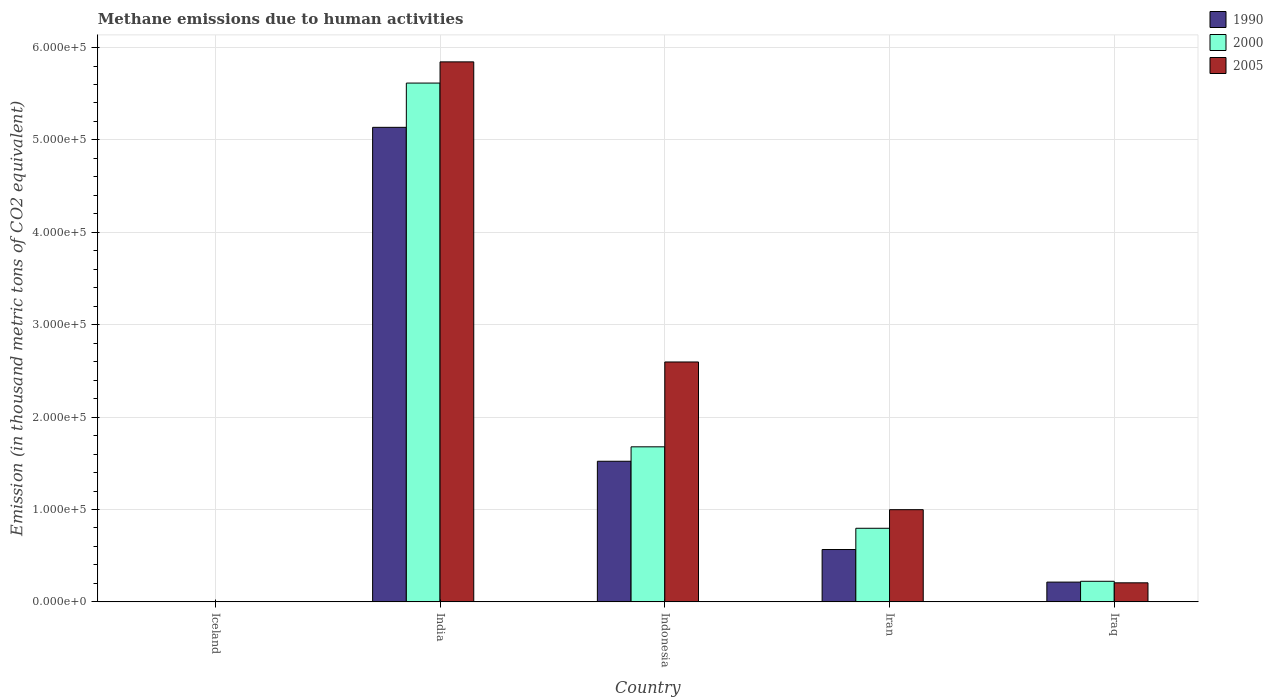How many different coloured bars are there?
Provide a succinct answer. 3. What is the label of the 5th group of bars from the left?
Provide a succinct answer. Iraq. What is the amount of methane emitted in 1990 in India?
Your response must be concise. 5.14e+05. Across all countries, what is the maximum amount of methane emitted in 2005?
Your response must be concise. 5.84e+05. Across all countries, what is the minimum amount of methane emitted in 2000?
Offer a very short reply. 336.5. What is the total amount of methane emitted in 2005 in the graph?
Make the answer very short. 9.65e+05. What is the difference between the amount of methane emitted in 2005 in India and that in Iraq?
Offer a very short reply. 5.64e+05. What is the difference between the amount of methane emitted in 1990 in India and the amount of methane emitted in 2005 in Iceland?
Make the answer very short. 5.13e+05. What is the average amount of methane emitted in 2000 per country?
Keep it short and to the point. 1.66e+05. What is the difference between the amount of methane emitted of/in 2005 and amount of methane emitted of/in 2000 in Iceland?
Your answer should be compact. -0.6. In how many countries, is the amount of methane emitted in 2000 greater than 140000 thousand metric tons?
Offer a terse response. 2. What is the ratio of the amount of methane emitted in 2005 in Indonesia to that in Iran?
Provide a short and direct response. 2.6. What is the difference between the highest and the second highest amount of methane emitted in 2005?
Ensure brevity in your answer.  -3.25e+05. What is the difference between the highest and the lowest amount of methane emitted in 2005?
Provide a succinct answer. 5.84e+05. In how many countries, is the amount of methane emitted in 2005 greater than the average amount of methane emitted in 2005 taken over all countries?
Keep it short and to the point. 2. What does the 1st bar from the left in Iraq represents?
Provide a short and direct response. 1990. What does the 3rd bar from the right in Iraq represents?
Your answer should be very brief. 1990. Is it the case that in every country, the sum of the amount of methane emitted in 2000 and amount of methane emitted in 1990 is greater than the amount of methane emitted in 2005?
Provide a short and direct response. Yes. How many countries are there in the graph?
Provide a short and direct response. 5. What is the title of the graph?
Provide a succinct answer. Methane emissions due to human activities. What is the label or title of the X-axis?
Your response must be concise. Country. What is the label or title of the Y-axis?
Offer a terse response. Emission (in thousand metric tons of CO2 equivalent). What is the Emission (in thousand metric tons of CO2 equivalent) in 1990 in Iceland?
Make the answer very short. 341.7. What is the Emission (in thousand metric tons of CO2 equivalent) of 2000 in Iceland?
Give a very brief answer. 336.5. What is the Emission (in thousand metric tons of CO2 equivalent) in 2005 in Iceland?
Your response must be concise. 335.9. What is the Emission (in thousand metric tons of CO2 equivalent) of 1990 in India?
Give a very brief answer. 5.14e+05. What is the Emission (in thousand metric tons of CO2 equivalent) of 2000 in India?
Your response must be concise. 5.62e+05. What is the Emission (in thousand metric tons of CO2 equivalent) of 2005 in India?
Your response must be concise. 5.84e+05. What is the Emission (in thousand metric tons of CO2 equivalent) of 1990 in Indonesia?
Your answer should be compact. 1.52e+05. What is the Emission (in thousand metric tons of CO2 equivalent) in 2000 in Indonesia?
Your answer should be very brief. 1.68e+05. What is the Emission (in thousand metric tons of CO2 equivalent) in 2005 in Indonesia?
Make the answer very short. 2.60e+05. What is the Emission (in thousand metric tons of CO2 equivalent) of 1990 in Iran?
Provide a short and direct response. 5.67e+04. What is the Emission (in thousand metric tons of CO2 equivalent) of 2000 in Iran?
Your answer should be compact. 7.97e+04. What is the Emission (in thousand metric tons of CO2 equivalent) of 2005 in Iran?
Your answer should be very brief. 9.98e+04. What is the Emission (in thousand metric tons of CO2 equivalent) in 1990 in Iraq?
Offer a very short reply. 2.14e+04. What is the Emission (in thousand metric tons of CO2 equivalent) in 2000 in Iraq?
Your answer should be compact. 2.23e+04. What is the Emission (in thousand metric tons of CO2 equivalent) in 2005 in Iraq?
Your answer should be very brief. 2.06e+04. Across all countries, what is the maximum Emission (in thousand metric tons of CO2 equivalent) in 1990?
Your answer should be compact. 5.14e+05. Across all countries, what is the maximum Emission (in thousand metric tons of CO2 equivalent) of 2000?
Your answer should be very brief. 5.62e+05. Across all countries, what is the maximum Emission (in thousand metric tons of CO2 equivalent) in 2005?
Offer a very short reply. 5.84e+05. Across all countries, what is the minimum Emission (in thousand metric tons of CO2 equivalent) of 1990?
Offer a terse response. 341.7. Across all countries, what is the minimum Emission (in thousand metric tons of CO2 equivalent) in 2000?
Your response must be concise. 336.5. Across all countries, what is the minimum Emission (in thousand metric tons of CO2 equivalent) of 2005?
Make the answer very short. 335.9. What is the total Emission (in thousand metric tons of CO2 equivalent) of 1990 in the graph?
Your answer should be compact. 7.44e+05. What is the total Emission (in thousand metric tons of CO2 equivalent) in 2000 in the graph?
Keep it short and to the point. 8.32e+05. What is the total Emission (in thousand metric tons of CO2 equivalent) of 2005 in the graph?
Keep it short and to the point. 9.65e+05. What is the difference between the Emission (in thousand metric tons of CO2 equivalent) of 1990 in Iceland and that in India?
Make the answer very short. -5.13e+05. What is the difference between the Emission (in thousand metric tons of CO2 equivalent) of 2000 in Iceland and that in India?
Offer a terse response. -5.61e+05. What is the difference between the Emission (in thousand metric tons of CO2 equivalent) in 2005 in Iceland and that in India?
Give a very brief answer. -5.84e+05. What is the difference between the Emission (in thousand metric tons of CO2 equivalent) in 1990 in Iceland and that in Indonesia?
Give a very brief answer. -1.52e+05. What is the difference between the Emission (in thousand metric tons of CO2 equivalent) in 2000 in Iceland and that in Indonesia?
Keep it short and to the point. -1.67e+05. What is the difference between the Emission (in thousand metric tons of CO2 equivalent) of 2005 in Iceland and that in Indonesia?
Give a very brief answer. -2.59e+05. What is the difference between the Emission (in thousand metric tons of CO2 equivalent) of 1990 in Iceland and that in Iran?
Your answer should be very brief. -5.63e+04. What is the difference between the Emission (in thousand metric tons of CO2 equivalent) of 2000 in Iceland and that in Iran?
Make the answer very short. -7.93e+04. What is the difference between the Emission (in thousand metric tons of CO2 equivalent) in 2005 in Iceland and that in Iran?
Offer a terse response. -9.95e+04. What is the difference between the Emission (in thousand metric tons of CO2 equivalent) of 1990 in Iceland and that in Iraq?
Your answer should be compact. -2.11e+04. What is the difference between the Emission (in thousand metric tons of CO2 equivalent) of 2000 in Iceland and that in Iraq?
Make the answer very short. -2.20e+04. What is the difference between the Emission (in thousand metric tons of CO2 equivalent) of 2005 in Iceland and that in Iraq?
Make the answer very short. -2.03e+04. What is the difference between the Emission (in thousand metric tons of CO2 equivalent) of 1990 in India and that in Indonesia?
Offer a terse response. 3.61e+05. What is the difference between the Emission (in thousand metric tons of CO2 equivalent) of 2000 in India and that in Indonesia?
Keep it short and to the point. 3.94e+05. What is the difference between the Emission (in thousand metric tons of CO2 equivalent) of 2005 in India and that in Indonesia?
Your answer should be compact. 3.25e+05. What is the difference between the Emission (in thousand metric tons of CO2 equivalent) in 1990 in India and that in Iran?
Offer a very short reply. 4.57e+05. What is the difference between the Emission (in thousand metric tons of CO2 equivalent) in 2000 in India and that in Iran?
Provide a succinct answer. 4.82e+05. What is the difference between the Emission (in thousand metric tons of CO2 equivalent) of 2005 in India and that in Iran?
Provide a short and direct response. 4.85e+05. What is the difference between the Emission (in thousand metric tons of CO2 equivalent) of 1990 in India and that in Iraq?
Your response must be concise. 4.92e+05. What is the difference between the Emission (in thousand metric tons of CO2 equivalent) of 2000 in India and that in Iraq?
Offer a very short reply. 5.39e+05. What is the difference between the Emission (in thousand metric tons of CO2 equivalent) of 2005 in India and that in Iraq?
Offer a terse response. 5.64e+05. What is the difference between the Emission (in thousand metric tons of CO2 equivalent) of 1990 in Indonesia and that in Iran?
Provide a succinct answer. 9.55e+04. What is the difference between the Emission (in thousand metric tons of CO2 equivalent) of 2000 in Indonesia and that in Iran?
Your answer should be compact. 8.82e+04. What is the difference between the Emission (in thousand metric tons of CO2 equivalent) in 2005 in Indonesia and that in Iran?
Offer a very short reply. 1.60e+05. What is the difference between the Emission (in thousand metric tons of CO2 equivalent) of 1990 in Indonesia and that in Iraq?
Provide a short and direct response. 1.31e+05. What is the difference between the Emission (in thousand metric tons of CO2 equivalent) in 2000 in Indonesia and that in Iraq?
Your response must be concise. 1.46e+05. What is the difference between the Emission (in thousand metric tons of CO2 equivalent) in 2005 in Indonesia and that in Iraq?
Ensure brevity in your answer.  2.39e+05. What is the difference between the Emission (in thousand metric tons of CO2 equivalent) of 1990 in Iran and that in Iraq?
Offer a terse response. 3.53e+04. What is the difference between the Emission (in thousand metric tons of CO2 equivalent) in 2000 in Iran and that in Iraq?
Offer a terse response. 5.74e+04. What is the difference between the Emission (in thousand metric tons of CO2 equivalent) of 2005 in Iran and that in Iraq?
Your answer should be compact. 7.92e+04. What is the difference between the Emission (in thousand metric tons of CO2 equivalent) of 1990 in Iceland and the Emission (in thousand metric tons of CO2 equivalent) of 2000 in India?
Your answer should be very brief. -5.61e+05. What is the difference between the Emission (in thousand metric tons of CO2 equivalent) in 1990 in Iceland and the Emission (in thousand metric tons of CO2 equivalent) in 2005 in India?
Your answer should be compact. -5.84e+05. What is the difference between the Emission (in thousand metric tons of CO2 equivalent) of 2000 in Iceland and the Emission (in thousand metric tons of CO2 equivalent) of 2005 in India?
Make the answer very short. -5.84e+05. What is the difference between the Emission (in thousand metric tons of CO2 equivalent) of 1990 in Iceland and the Emission (in thousand metric tons of CO2 equivalent) of 2000 in Indonesia?
Offer a very short reply. -1.67e+05. What is the difference between the Emission (in thousand metric tons of CO2 equivalent) in 1990 in Iceland and the Emission (in thousand metric tons of CO2 equivalent) in 2005 in Indonesia?
Provide a short and direct response. -2.59e+05. What is the difference between the Emission (in thousand metric tons of CO2 equivalent) of 2000 in Iceland and the Emission (in thousand metric tons of CO2 equivalent) of 2005 in Indonesia?
Keep it short and to the point. -2.59e+05. What is the difference between the Emission (in thousand metric tons of CO2 equivalent) in 1990 in Iceland and the Emission (in thousand metric tons of CO2 equivalent) in 2000 in Iran?
Provide a succinct answer. -7.93e+04. What is the difference between the Emission (in thousand metric tons of CO2 equivalent) in 1990 in Iceland and the Emission (in thousand metric tons of CO2 equivalent) in 2005 in Iran?
Ensure brevity in your answer.  -9.94e+04. What is the difference between the Emission (in thousand metric tons of CO2 equivalent) of 2000 in Iceland and the Emission (in thousand metric tons of CO2 equivalent) of 2005 in Iran?
Offer a terse response. -9.95e+04. What is the difference between the Emission (in thousand metric tons of CO2 equivalent) in 1990 in Iceland and the Emission (in thousand metric tons of CO2 equivalent) in 2000 in Iraq?
Offer a terse response. -2.19e+04. What is the difference between the Emission (in thousand metric tons of CO2 equivalent) in 1990 in Iceland and the Emission (in thousand metric tons of CO2 equivalent) in 2005 in Iraq?
Ensure brevity in your answer.  -2.03e+04. What is the difference between the Emission (in thousand metric tons of CO2 equivalent) of 2000 in Iceland and the Emission (in thousand metric tons of CO2 equivalent) of 2005 in Iraq?
Offer a very short reply. -2.03e+04. What is the difference between the Emission (in thousand metric tons of CO2 equivalent) in 1990 in India and the Emission (in thousand metric tons of CO2 equivalent) in 2000 in Indonesia?
Provide a short and direct response. 3.46e+05. What is the difference between the Emission (in thousand metric tons of CO2 equivalent) of 1990 in India and the Emission (in thousand metric tons of CO2 equivalent) of 2005 in Indonesia?
Keep it short and to the point. 2.54e+05. What is the difference between the Emission (in thousand metric tons of CO2 equivalent) in 2000 in India and the Emission (in thousand metric tons of CO2 equivalent) in 2005 in Indonesia?
Provide a succinct answer. 3.02e+05. What is the difference between the Emission (in thousand metric tons of CO2 equivalent) of 1990 in India and the Emission (in thousand metric tons of CO2 equivalent) of 2000 in Iran?
Give a very brief answer. 4.34e+05. What is the difference between the Emission (in thousand metric tons of CO2 equivalent) in 1990 in India and the Emission (in thousand metric tons of CO2 equivalent) in 2005 in Iran?
Your answer should be compact. 4.14e+05. What is the difference between the Emission (in thousand metric tons of CO2 equivalent) of 2000 in India and the Emission (in thousand metric tons of CO2 equivalent) of 2005 in Iran?
Your answer should be very brief. 4.62e+05. What is the difference between the Emission (in thousand metric tons of CO2 equivalent) of 1990 in India and the Emission (in thousand metric tons of CO2 equivalent) of 2000 in Iraq?
Your response must be concise. 4.91e+05. What is the difference between the Emission (in thousand metric tons of CO2 equivalent) of 1990 in India and the Emission (in thousand metric tons of CO2 equivalent) of 2005 in Iraq?
Provide a succinct answer. 4.93e+05. What is the difference between the Emission (in thousand metric tons of CO2 equivalent) in 2000 in India and the Emission (in thousand metric tons of CO2 equivalent) in 2005 in Iraq?
Give a very brief answer. 5.41e+05. What is the difference between the Emission (in thousand metric tons of CO2 equivalent) in 1990 in Indonesia and the Emission (in thousand metric tons of CO2 equivalent) in 2000 in Iran?
Keep it short and to the point. 7.25e+04. What is the difference between the Emission (in thousand metric tons of CO2 equivalent) of 1990 in Indonesia and the Emission (in thousand metric tons of CO2 equivalent) of 2005 in Iran?
Provide a short and direct response. 5.24e+04. What is the difference between the Emission (in thousand metric tons of CO2 equivalent) in 2000 in Indonesia and the Emission (in thousand metric tons of CO2 equivalent) in 2005 in Iran?
Provide a succinct answer. 6.80e+04. What is the difference between the Emission (in thousand metric tons of CO2 equivalent) of 1990 in Indonesia and the Emission (in thousand metric tons of CO2 equivalent) of 2000 in Iraq?
Provide a short and direct response. 1.30e+05. What is the difference between the Emission (in thousand metric tons of CO2 equivalent) of 1990 in Indonesia and the Emission (in thousand metric tons of CO2 equivalent) of 2005 in Iraq?
Give a very brief answer. 1.32e+05. What is the difference between the Emission (in thousand metric tons of CO2 equivalent) in 2000 in Indonesia and the Emission (in thousand metric tons of CO2 equivalent) in 2005 in Iraq?
Give a very brief answer. 1.47e+05. What is the difference between the Emission (in thousand metric tons of CO2 equivalent) of 1990 in Iran and the Emission (in thousand metric tons of CO2 equivalent) of 2000 in Iraq?
Provide a short and direct response. 3.44e+04. What is the difference between the Emission (in thousand metric tons of CO2 equivalent) in 1990 in Iran and the Emission (in thousand metric tons of CO2 equivalent) in 2005 in Iraq?
Your answer should be compact. 3.60e+04. What is the difference between the Emission (in thousand metric tons of CO2 equivalent) of 2000 in Iran and the Emission (in thousand metric tons of CO2 equivalent) of 2005 in Iraq?
Offer a very short reply. 5.90e+04. What is the average Emission (in thousand metric tons of CO2 equivalent) in 1990 per country?
Provide a short and direct response. 1.49e+05. What is the average Emission (in thousand metric tons of CO2 equivalent) of 2000 per country?
Offer a terse response. 1.66e+05. What is the average Emission (in thousand metric tons of CO2 equivalent) in 2005 per country?
Ensure brevity in your answer.  1.93e+05. What is the difference between the Emission (in thousand metric tons of CO2 equivalent) of 1990 and Emission (in thousand metric tons of CO2 equivalent) of 2000 in Iceland?
Give a very brief answer. 5.2. What is the difference between the Emission (in thousand metric tons of CO2 equivalent) in 1990 and Emission (in thousand metric tons of CO2 equivalent) in 2000 in India?
Keep it short and to the point. -4.79e+04. What is the difference between the Emission (in thousand metric tons of CO2 equivalent) of 1990 and Emission (in thousand metric tons of CO2 equivalent) of 2005 in India?
Offer a very short reply. -7.09e+04. What is the difference between the Emission (in thousand metric tons of CO2 equivalent) in 2000 and Emission (in thousand metric tons of CO2 equivalent) in 2005 in India?
Make the answer very short. -2.29e+04. What is the difference between the Emission (in thousand metric tons of CO2 equivalent) of 1990 and Emission (in thousand metric tons of CO2 equivalent) of 2000 in Indonesia?
Offer a terse response. -1.56e+04. What is the difference between the Emission (in thousand metric tons of CO2 equivalent) in 1990 and Emission (in thousand metric tons of CO2 equivalent) in 2005 in Indonesia?
Your response must be concise. -1.07e+05. What is the difference between the Emission (in thousand metric tons of CO2 equivalent) in 2000 and Emission (in thousand metric tons of CO2 equivalent) in 2005 in Indonesia?
Make the answer very short. -9.18e+04. What is the difference between the Emission (in thousand metric tons of CO2 equivalent) of 1990 and Emission (in thousand metric tons of CO2 equivalent) of 2000 in Iran?
Your answer should be compact. -2.30e+04. What is the difference between the Emission (in thousand metric tons of CO2 equivalent) in 1990 and Emission (in thousand metric tons of CO2 equivalent) in 2005 in Iran?
Give a very brief answer. -4.31e+04. What is the difference between the Emission (in thousand metric tons of CO2 equivalent) in 2000 and Emission (in thousand metric tons of CO2 equivalent) in 2005 in Iran?
Keep it short and to the point. -2.01e+04. What is the difference between the Emission (in thousand metric tons of CO2 equivalent) in 1990 and Emission (in thousand metric tons of CO2 equivalent) in 2000 in Iraq?
Make the answer very short. -893.7. What is the difference between the Emission (in thousand metric tons of CO2 equivalent) of 1990 and Emission (in thousand metric tons of CO2 equivalent) of 2005 in Iraq?
Ensure brevity in your answer.  767.2. What is the difference between the Emission (in thousand metric tons of CO2 equivalent) in 2000 and Emission (in thousand metric tons of CO2 equivalent) in 2005 in Iraq?
Keep it short and to the point. 1660.9. What is the ratio of the Emission (in thousand metric tons of CO2 equivalent) in 1990 in Iceland to that in India?
Your response must be concise. 0. What is the ratio of the Emission (in thousand metric tons of CO2 equivalent) in 2000 in Iceland to that in India?
Provide a succinct answer. 0. What is the ratio of the Emission (in thousand metric tons of CO2 equivalent) of 2005 in Iceland to that in India?
Ensure brevity in your answer.  0. What is the ratio of the Emission (in thousand metric tons of CO2 equivalent) in 1990 in Iceland to that in Indonesia?
Provide a succinct answer. 0. What is the ratio of the Emission (in thousand metric tons of CO2 equivalent) of 2000 in Iceland to that in Indonesia?
Offer a terse response. 0. What is the ratio of the Emission (in thousand metric tons of CO2 equivalent) in 2005 in Iceland to that in Indonesia?
Provide a short and direct response. 0. What is the ratio of the Emission (in thousand metric tons of CO2 equivalent) in 1990 in Iceland to that in Iran?
Provide a succinct answer. 0.01. What is the ratio of the Emission (in thousand metric tons of CO2 equivalent) of 2000 in Iceland to that in Iran?
Keep it short and to the point. 0. What is the ratio of the Emission (in thousand metric tons of CO2 equivalent) in 2005 in Iceland to that in Iran?
Your answer should be very brief. 0. What is the ratio of the Emission (in thousand metric tons of CO2 equivalent) in 1990 in Iceland to that in Iraq?
Your answer should be very brief. 0.02. What is the ratio of the Emission (in thousand metric tons of CO2 equivalent) of 2000 in Iceland to that in Iraq?
Provide a succinct answer. 0.02. What is the ratio of the Emission (in thousand metric tons of CO2 equivalent) of 2005 in Iceland to that in Iraq?
Provide a short and direct response. 0.02. What is the ratio of the Emission (in thousand metric tons of CO2 equivalent) of 1990 in India to that in Indonesia?
Offer a very short reply. 3.37. What is the ratio of the Emission (in thousand metric tons of CO2 equivalent) in 2000 in India to that in Indonesia?
Your answer should be compact. 3.35. What is the ratio of the Emission (in thousand metric tons of CO2 equivalent) in 2005 in India to that in Indonesia?
Your answer should be very brief. 2.25. What is the ratio of the Emission (in thousand metric tons of CO2 equivalent) in 1990 in India to that in Iran?
Provide a short and direct response. 9.06. What is the ratio of the Emission (in thousand metric tons of CO2 equivalent) in 2000 in India to that in Iran?
Your answer should be compact. 7.05. What is the ratio of the Emission (in thousand metric tons of CO2 equivalent) in 2005 in India to that in Iran?
Provide a succinct answer. 5.86. What is the ratio of the Emission (in thousand metric tons of CO2 equivalent) in 1990 in India to that in Iraq?
Provide a succinct answer. 24.01. What is the ratio of the Emission (in thousand metric tons of CO2 equivalent) in 2000 in India to that in Iraq?
Offer a terse response. 25.19. What is the ratio of the Emission (in thousand metric tons of CO2 equivalent) of 2005 in India to that in Iraq?
Your answer should be compact. 28.33. What is the ratio of the Emission (in thousand metric tons of CO2 equivalent) in 1990 in Indonesia to that in Iran?
Your answer should be very brief. 2.69. What is the ratio of the Emission (in thousand metric tons of CO2 equivalent) of 2000 in Indonesia to that in Iran?
Offer a very short reply. 2.11. What is the ratio of the Emission (in thousand metric tons of CO2 equivalent) in 2005 in Indonesia to that in Iran?
Give a very brief answer. 2.6. What is the ratio of the Emission (in thousand metric tons of CO2 equivalent) of 1990 in Indonesia to that in Iraq?
Make the answer very short. 7.11. What is the ratio of the Emission (in thousand metric tons of CO2 equivalent) of 2000 in Indonesia to that in Iraq?
Your response must be concise. 7.53. What is the ratio of the Emission (in thousand metric tons of CO2 equivalent) of 2005 in Indonesia to that in Iraq?
Your answer should be very brief. 12.59. What is the ratio of the Emission (in thousand metric tons of CO2 equivalent) of 1990 in Iran to that in Iraq?
Make the answer very short. 2.65. What is the ratio of the Emission (in thousand metric tons of CO2 equivalent) of 2000 in Iran to that in Iraq?
Your response must be concise. 3.57. What is the ratio of the Emission (in thousand metric tons of CO2 equivalent) of 2005 in Iran to that in Iraq?
Your response must be concise. 4.84. What is the difference between the highest and the second highest Emission (in thousand metric tons of CO2 equivalent) in 1990?
Offer a very short reply. 3.61e+05. What is the difference between the highest and the second highest Emission (in thousand metric tons of CO2 equivalent) of 2000?
Keep it short and to the point. 3.94e+05. What is the difference between the highest and the second highest Emission (in thousand metric tons of CO2 equivalent) of 2005?
Offer a very short reply. 3.25e+05. What is the difference between the highest and the lowest Emission (in thousand metric tons of CO2 equivalent) in 1990?
Provide a succinct answer. 5.13e+05. What is the difference between the highest and the lowest Emission (in thousand metric tons of CO2 equivalent) in 2000?
Make the answer very short. 5.61e+05. What is the difference between the highest and the lowest Emission (in thousand metric tons of CO2 equivalent) in 2005?
Your answer should be very brief. 5.84e+05. 